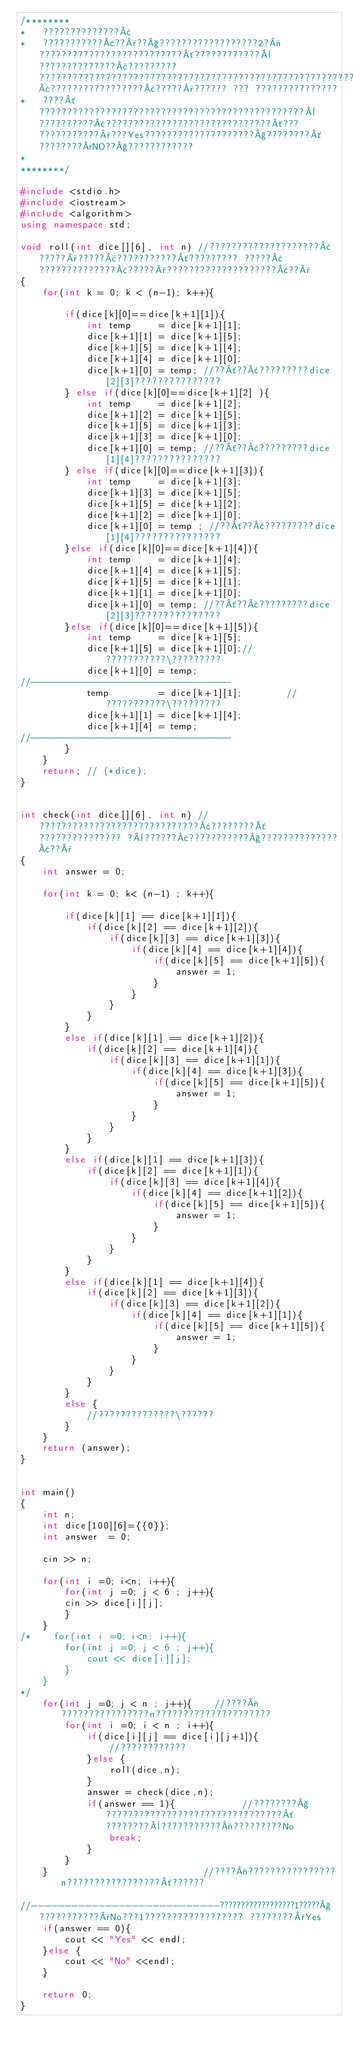<code> <loc_0><loc_0><loc_500><loc_500><_C++_>/********
*	??????????????£
*	???????????¢??°??§??????????????????2?¬??????????????????????????´????????????¨??????????????£????????? ?????????????????????????????????????????????????????????????????????????????¢?????????????????¢?????°?????? ??? ???????????????
*	????´????????????????????????????????????????????????¨??????????¢??????????????????????????????´??? ???????????°???Yes????????????????????§????????´????????°NO??§????????????
*
********/

#include <stdio.h>
#include <iostream>
#include <algorithm>
using namespace std;

void roll(int dice[][6], int n) //????????????????????¢?????°?????£???????????´????????? ?????¢??????????????¢?????°????????????????????¢??°
{
	for(int k = 0; k < (n-1); k++){
			
		if(dice[k][0]==dice[k+1][1]){
			int temp     = dice[k+1][1];
			dice[k+1][1] = dice[k+1][5];
			dice[k+1][5] = dice[k+1][4];
			dice[k+1][4] = dice[k+1][0];
			dice[k+1][0] = temp; //??´??¢?????????dice[2][3]???????????????
		} else if(dice[k][0]==dice[k+1][2] ){
			int temp     = dice[k+1][2];
			dice[k+1][2] = dice[k+1][5];
			dice[k+1][5] = dice[k+1][3];
			dice[k+1][3] = dice[k+1][0];
			dice[k+1][0] = temp; //??´??¢?????????dice[1][4]???????????????
		} else if(dice[k][0]==dice[k+1][3]){
			int temp     = dice[k+1][3];
			dice[k+1][3] = dice[k+1][5];
			dice[k+1][5] = dice[k+1][2];
			dice[k+1][2] = dice[k+1][0];
			dice[k+1][0] = temp ; //??´??¢?????????dice[1][4]???????????????
		}else if(dice[k][0]==dice[k+1][4]){
			int temp     = dice[k+1][4];
			dice[k+1][4] = dice[k+1][5];
			dice[k+1][5] = dice[k+1][1];
			dice[k+1][1] = dice[k+1][0];
			dice[k+1][0] = temp; //??´??¢?????????dice[2][3]???????????????
		}else if(dice[k][0]==dice[k+1][5]){
			int temp	 = dice[k+1][5];
			dice[k+1][5] = dice[k+1][0];//???????????\?????????
			dice[k+1][0] = temp;
//------------------------------------
			temp         = dice[k+1][1];        //???????????\?????????
			dice[k+1][1] = dice[k+1][4];
			dice[k+1][4] = temp;
//------------------------------------
        }
    }
    return; // (*dice);
}


int check(int dice[][6], int n) //?????????????????????????????¢????????´??????????????? ?¨??????¢???????????§??????????????¢??°
{
    int answer = 0;

    for(int k = 0; k< (n-1) ; k++){

        if(dice[k][1] == dice[k+1][1]){
			if(dice[k][2] == dice[k+1][2]){
				if(dice[k][3] == dice[k+1][3]){
					if(dice[k][4] == dice[k+1][4]){
						if(dice[k][5] == dice[k+1][5]){
							answer = 1;
						}
					}
				}
			}
		}
    	else if(dice[k][1] == dice[k+1][2]){
			if(dice[k][2] == dice[k+1][4]){
				if(dice[k][3] == dice[k+1][1]){
					if(dice[k][4] == dice[k+1][3]){
						if(dice[k][5] == dice[k+1][5]){
							answer = 1;
						}
					}
				}
			}
		}
		else if(dice[k][1] == dice[k+1][3]){
			if(dice[k][2] == dice[k+1][1]){
				if(dice[k][3] == dice[k+1][4]){
					if(dice[k][4] == dice[k+1][2]){
						if(dice[k][5] == dice[k+1][5]){
							answer = 1;
						}
					}
				}
			}
		}
		else if(dice[k][1] == dice[k+1][4]){
			if(dice[k][2] == dice[k+1][3]){
				if(dice[k][3] == dice[k+1][2]){
					if(dice[k][4] == dice[k+1][1]){
						if(dice[k][5] == dice[k+1][5]){
							answer = 1;
						}
					}
				}
			}
		}
    	else {
			//??????????????\??????
		}
    }
    return (answer);
}


int main()
{
	int n;
	int dice[100][6]={{0}};
	int answer  = 0;
	
	cin >> n;
	
	for(int i =0; i<n; i++){
		for(int j =0; j < 6 ; j++){
		cin >> dice[i][j];
		}
	}
/*    for(int i =0; i<n; i++){
		for(int j =0; j < 6 ; j++){
			cout << dice[i][j];
		}
	}
*/
    for(int j =0; j < n ; j++){    //????¬????????????????n?????????????????????
        for(int i =0; i < n ; i++){
			if(dice[i][j] == dice[i][j+1]){
				//????????????
			}else {
				roll(dice,n);
			}
			answer = check(dice,n);
			if(answer == 1){            //????????§????????????????????????????????´ ????????¨???????????¬?????????No
				break;
			}
		}
	}                            //????¬????????????????n?????????????????´??????

//----------------------------??????????????????1?????§???????????°No???1?????????????????? ????????°Yes
    if(answer == 0){
        cout << "Yes" << endl;
    }else {
        cout << "No" <<endl;
    }

    return 0;
}</code> 